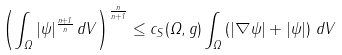Convert formula to latex. <formula><loc_0><loc_0><loc_500><loc_500>\left ( \int _ { \Omega } | \psi | ^ { \frac { n + 1 } { n } } \, d V \right ) ^ { \frac { n } { n + 1 } } \leq c _ { S } ( \Omega , g ) \int _ { \Omega } \left ( | \nabla \psi | + | \psi | \right ) \, d V</formula> 